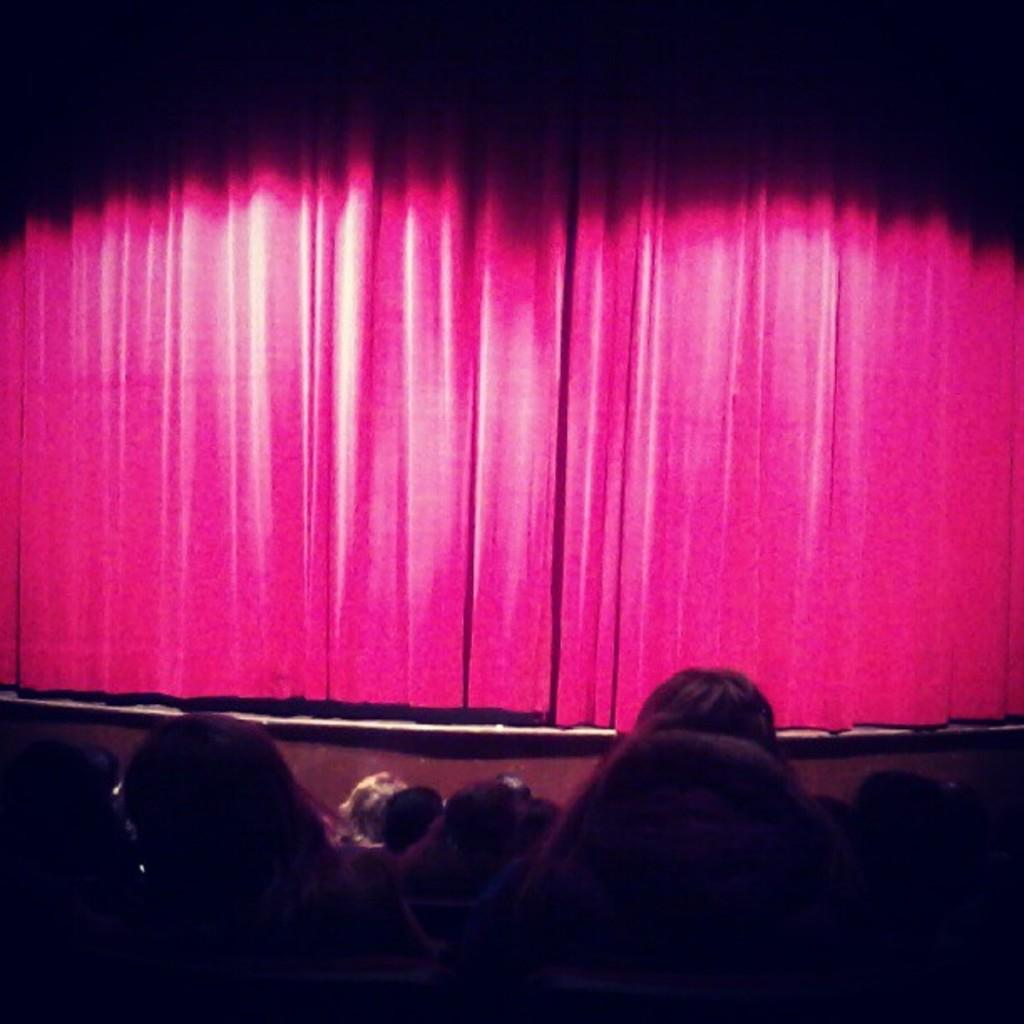How many people are in the group visible in the image? The number of people in the group cannot be determined from the provided facts. What is the main feature of the image besides the group of people? There appears to be a stage in the image. What type of covering is present in the image? There are curtains in the image. What is the interest of the sun in the image? The sun is a celestial body and does not have interests; it is simply visible in the sky. What type of lamp is present on the stage in the image? There is no lamp present on the stage in the image. 